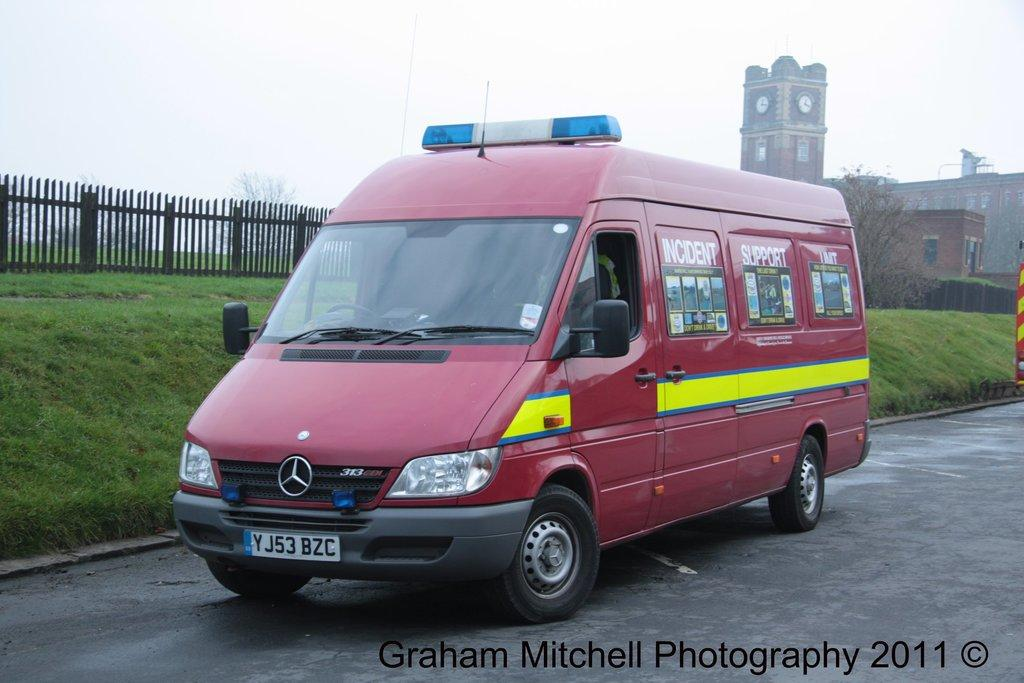<image>
Share a concise interpretation of the image provided. a graham mitchell photo of a red van 